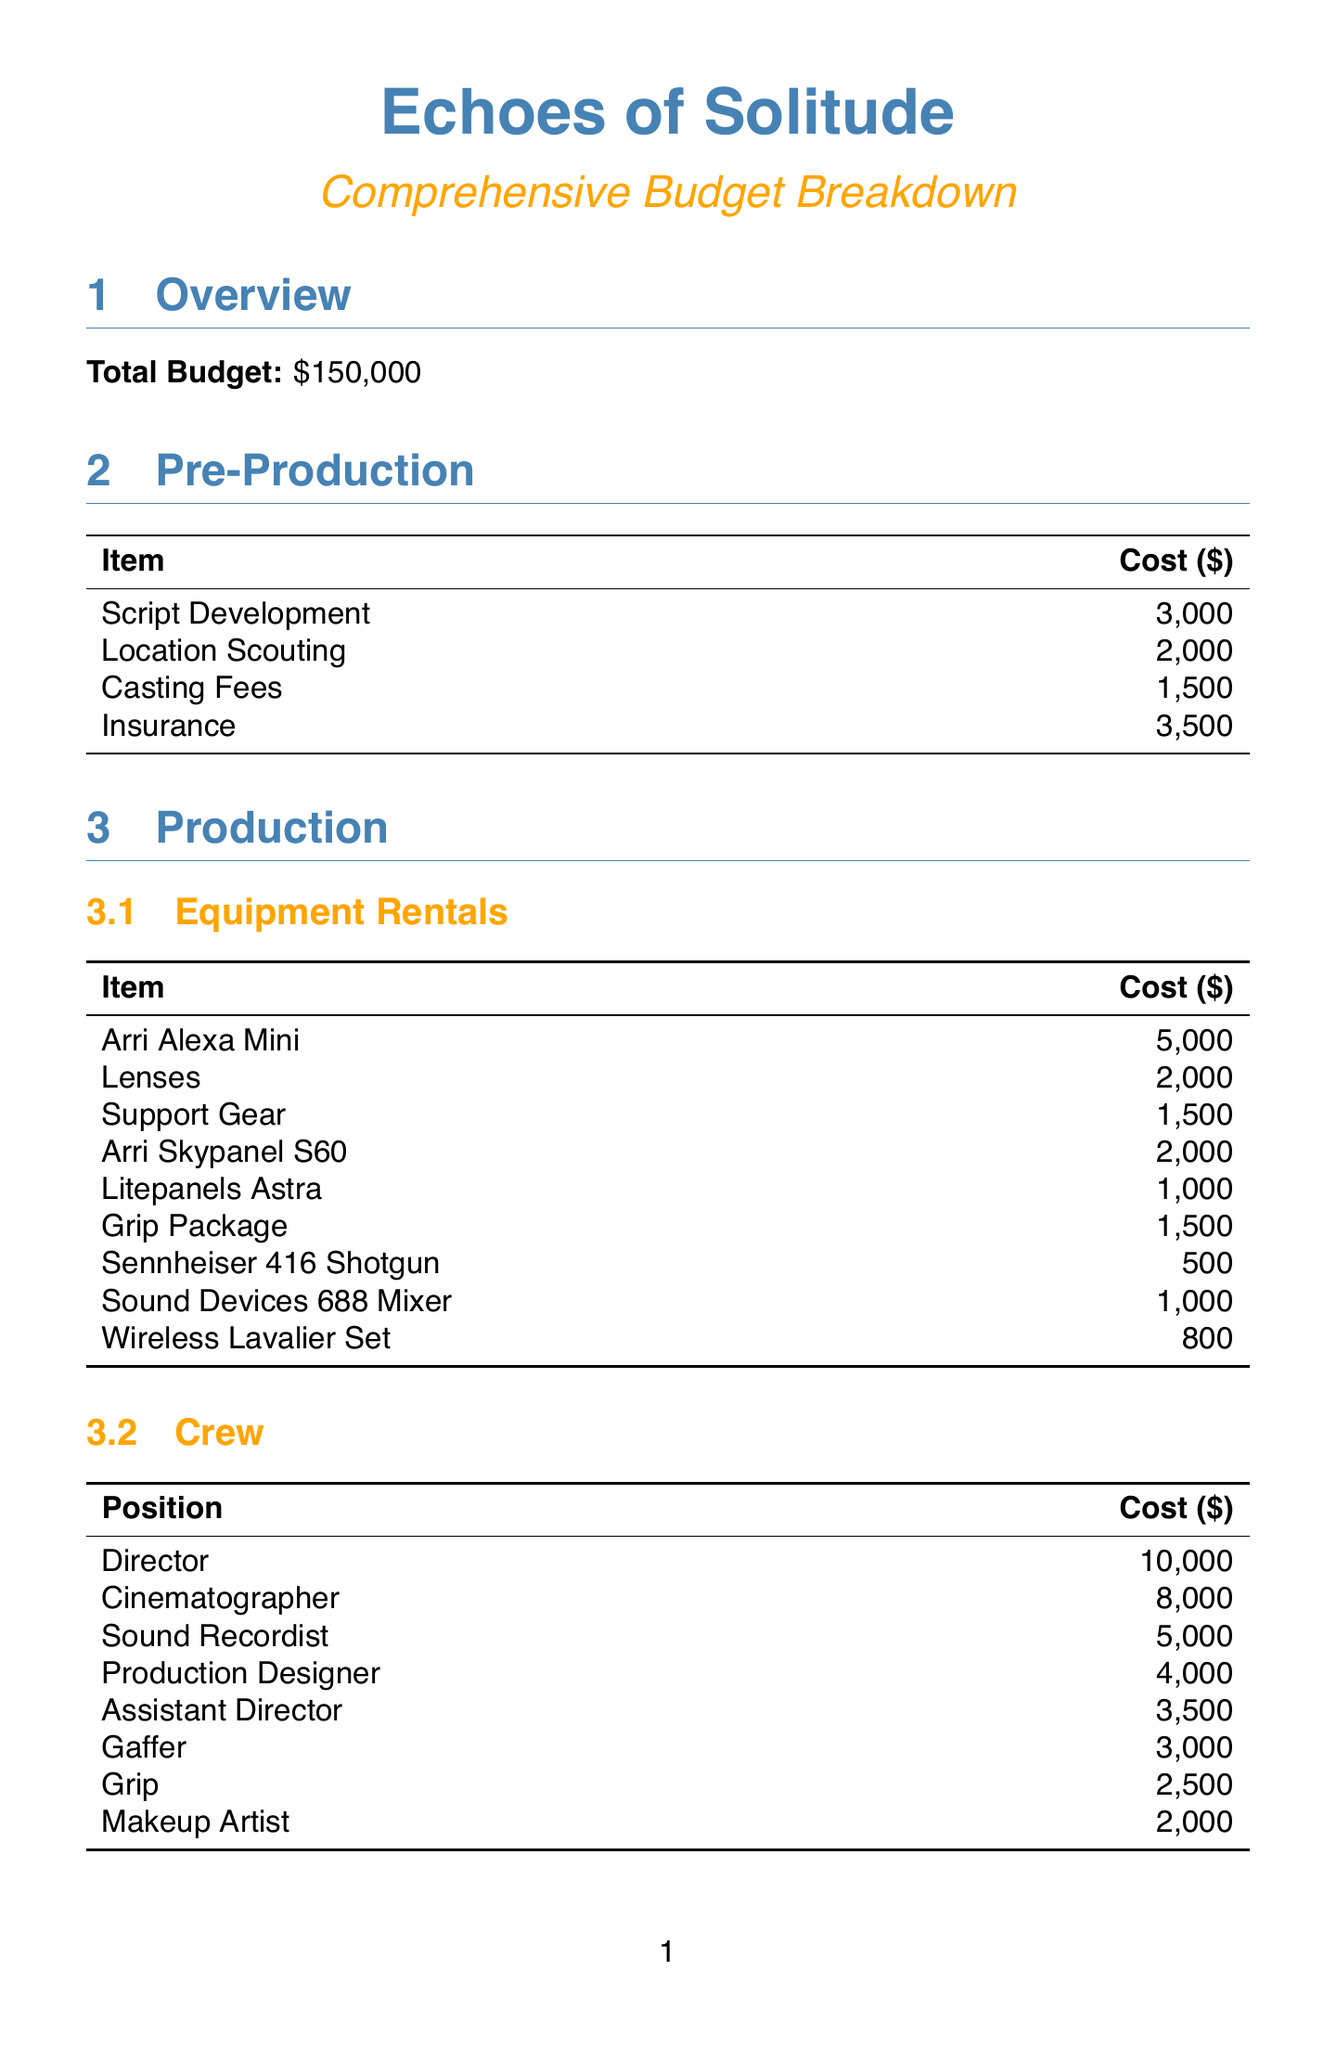What is the total budget? The total budget is clearly stated at the beginning of the document as $150,000.
Answer: $150,000 How much is allocated for pre-production scripting? The document specifies the cost for script development under pre-production as $3,000.
Answer: $3,000 What is the highest cost for crew members? The highest cost for a crew member is listed for the director at $10,000.
Answer: $10,000 How many locations are mentioned in the production section? The document lists four locations under the production section, making it a straightforward count.
Answer: Four What is the total price for sound design in post-production? The sum of the sound design costs includes $4,000 (Sound Editor) + $300 (Pro Tools Subscription) + $3,000 (Music Licensing), totaling this amount.
Answer: $7,300 Which camera rental is the most expensive? The document indicates that the Arri Alexa Mini is the most expensive camera rental at $5,000.
Answer: Arri Alexa Mini What percentage of the total budget is allocated for cast expenses? The total cast expenses amount to $31,000, which is calculated as a percentage of the total budget.
Answer: 20.67% What is the contingency fund amount? The document states the amount set aside for contingency funds as $13,000.
Answer: $13,000 What editing software is listed in post-production? The document specifically mentions Adobe Creative Suite as the editing software needed during post-production.
Answer: Adobe Creative Suite 